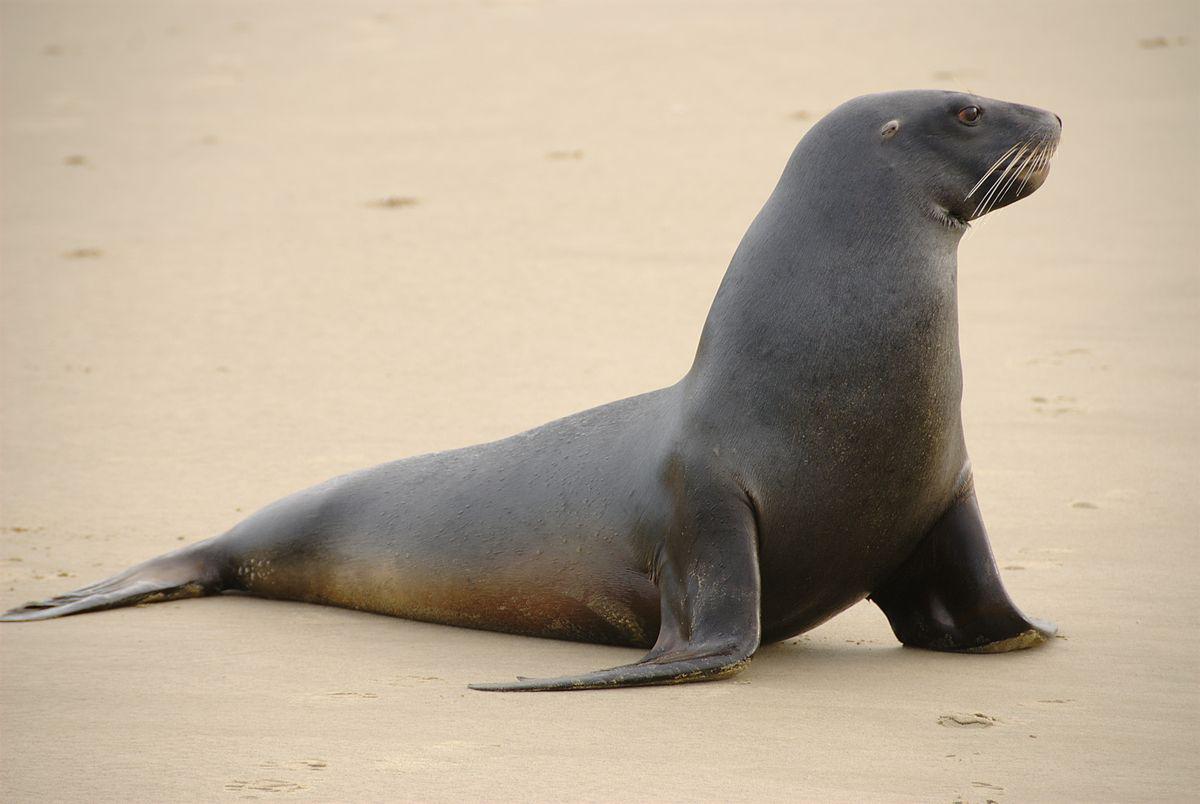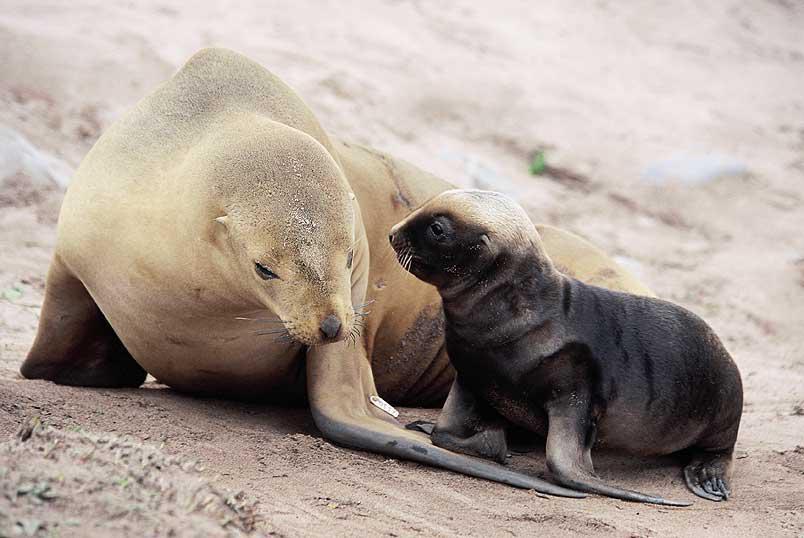The first image is the image on the left, the second image is the image on the right. Analyze the images presented: Is the assertion "A single animal is looking toward the camera in the image on the left." valid? Answer yes or no. No. The first image is the image on the left, the second image is the image on the right. Examine the images to the left and right. Is the description "In the foreground of an image, a left-facing small dark seal has its nose close to a bigger, paler seal." accurate? Answer yes or no. Yes. 